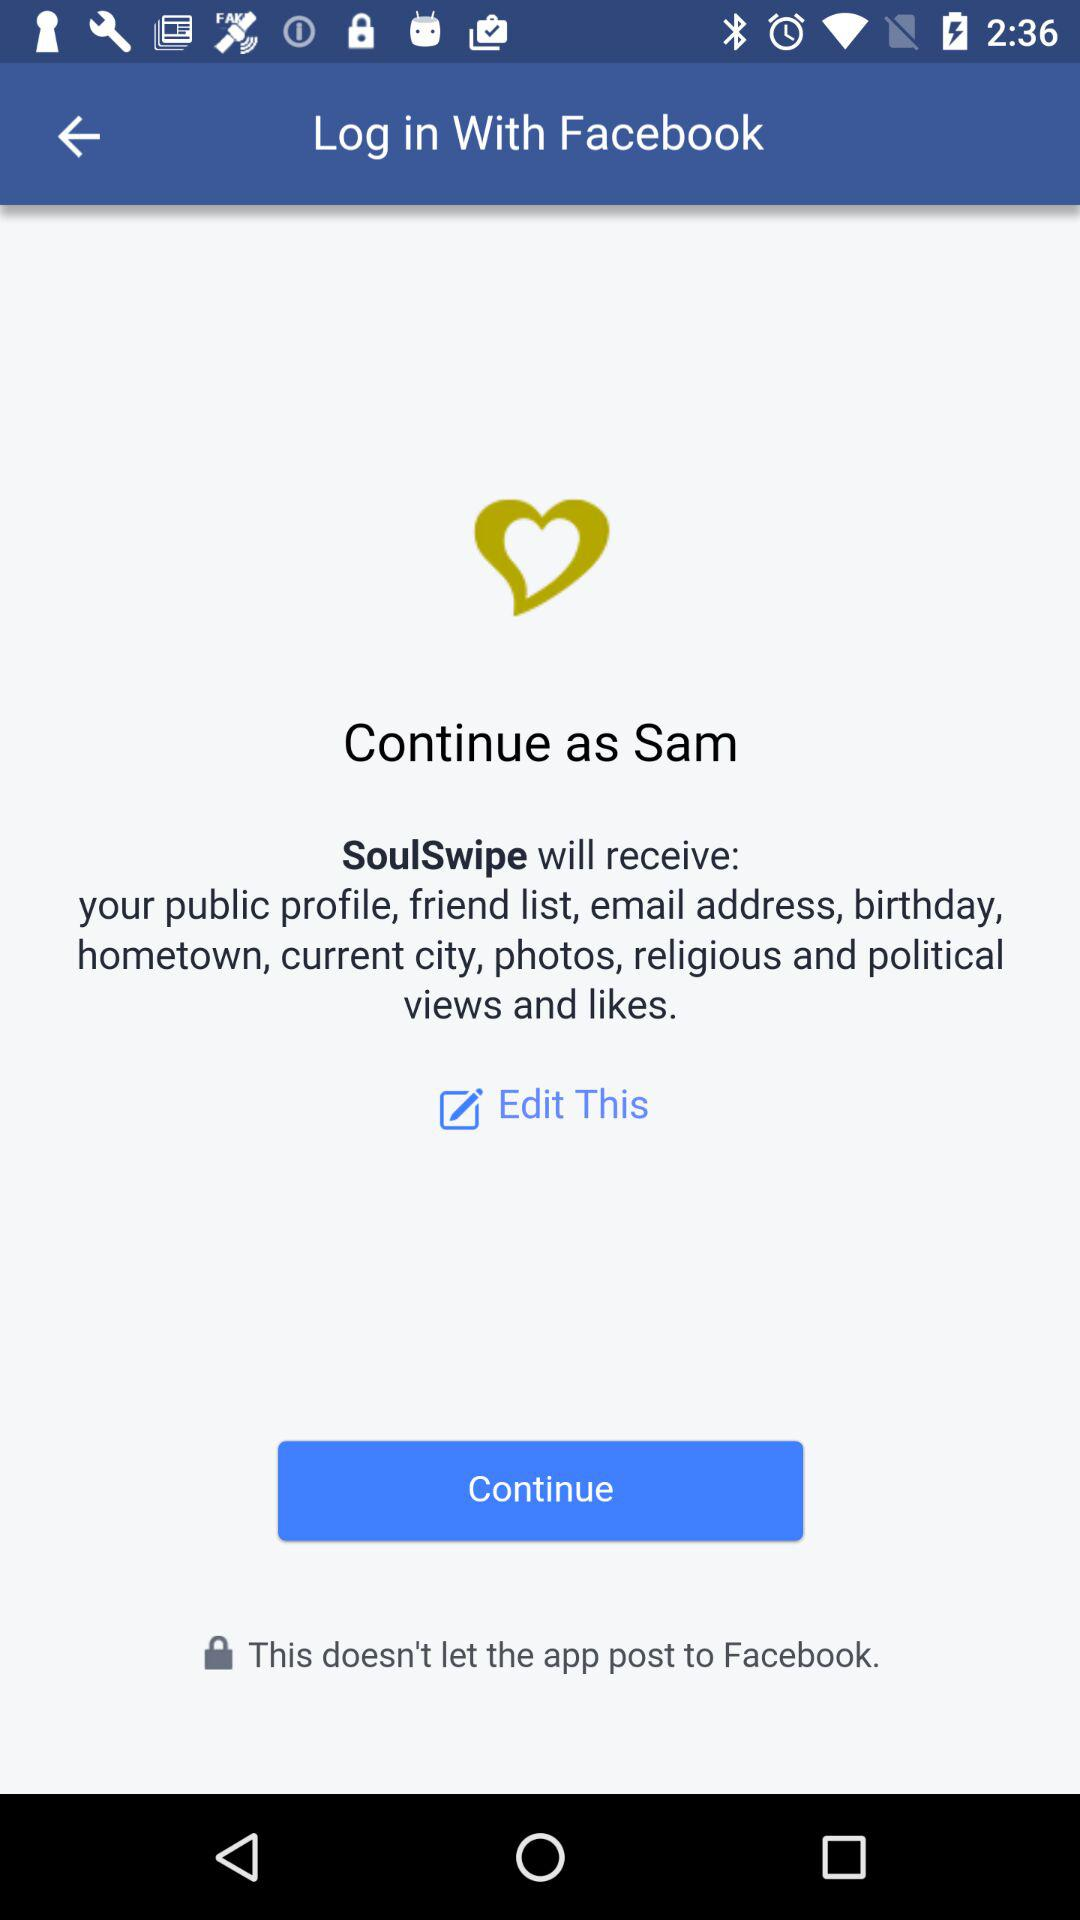Which option is selected?
When the provided information is insufficient, respond with <no answer>. <no answer> 